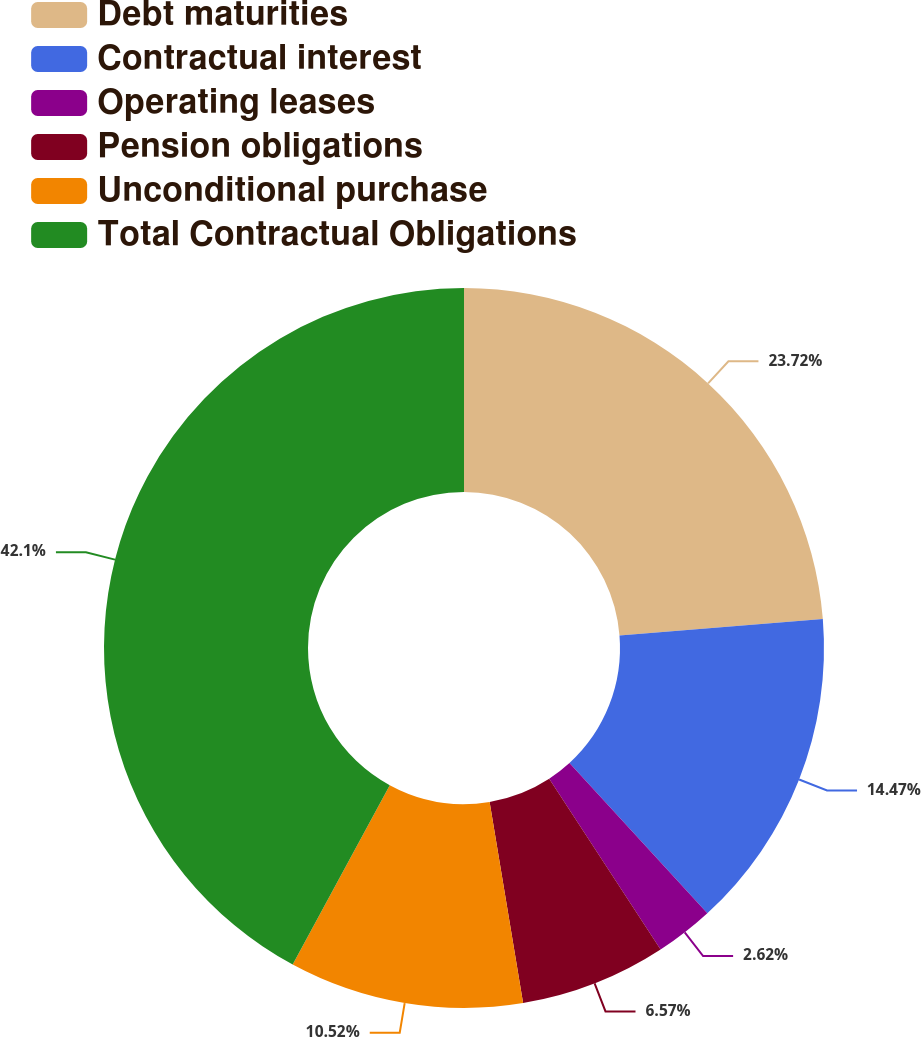Convert chart. <chart><loc_0><loc_0><loc_500><loc_500><pie_chart><fcel>Debt maturities<fcel>Contractual interest<fcel>Operating leases<fcel>Pension obligations<fcel>Unconditional purchase<fcel>Total Contractual Obligations<nl><fcel>23.72%<fcel>14.47%<fcel>2.62%<fcel>6.57%<fcel>10.52%<fcel>42.11%<nl></chart> 